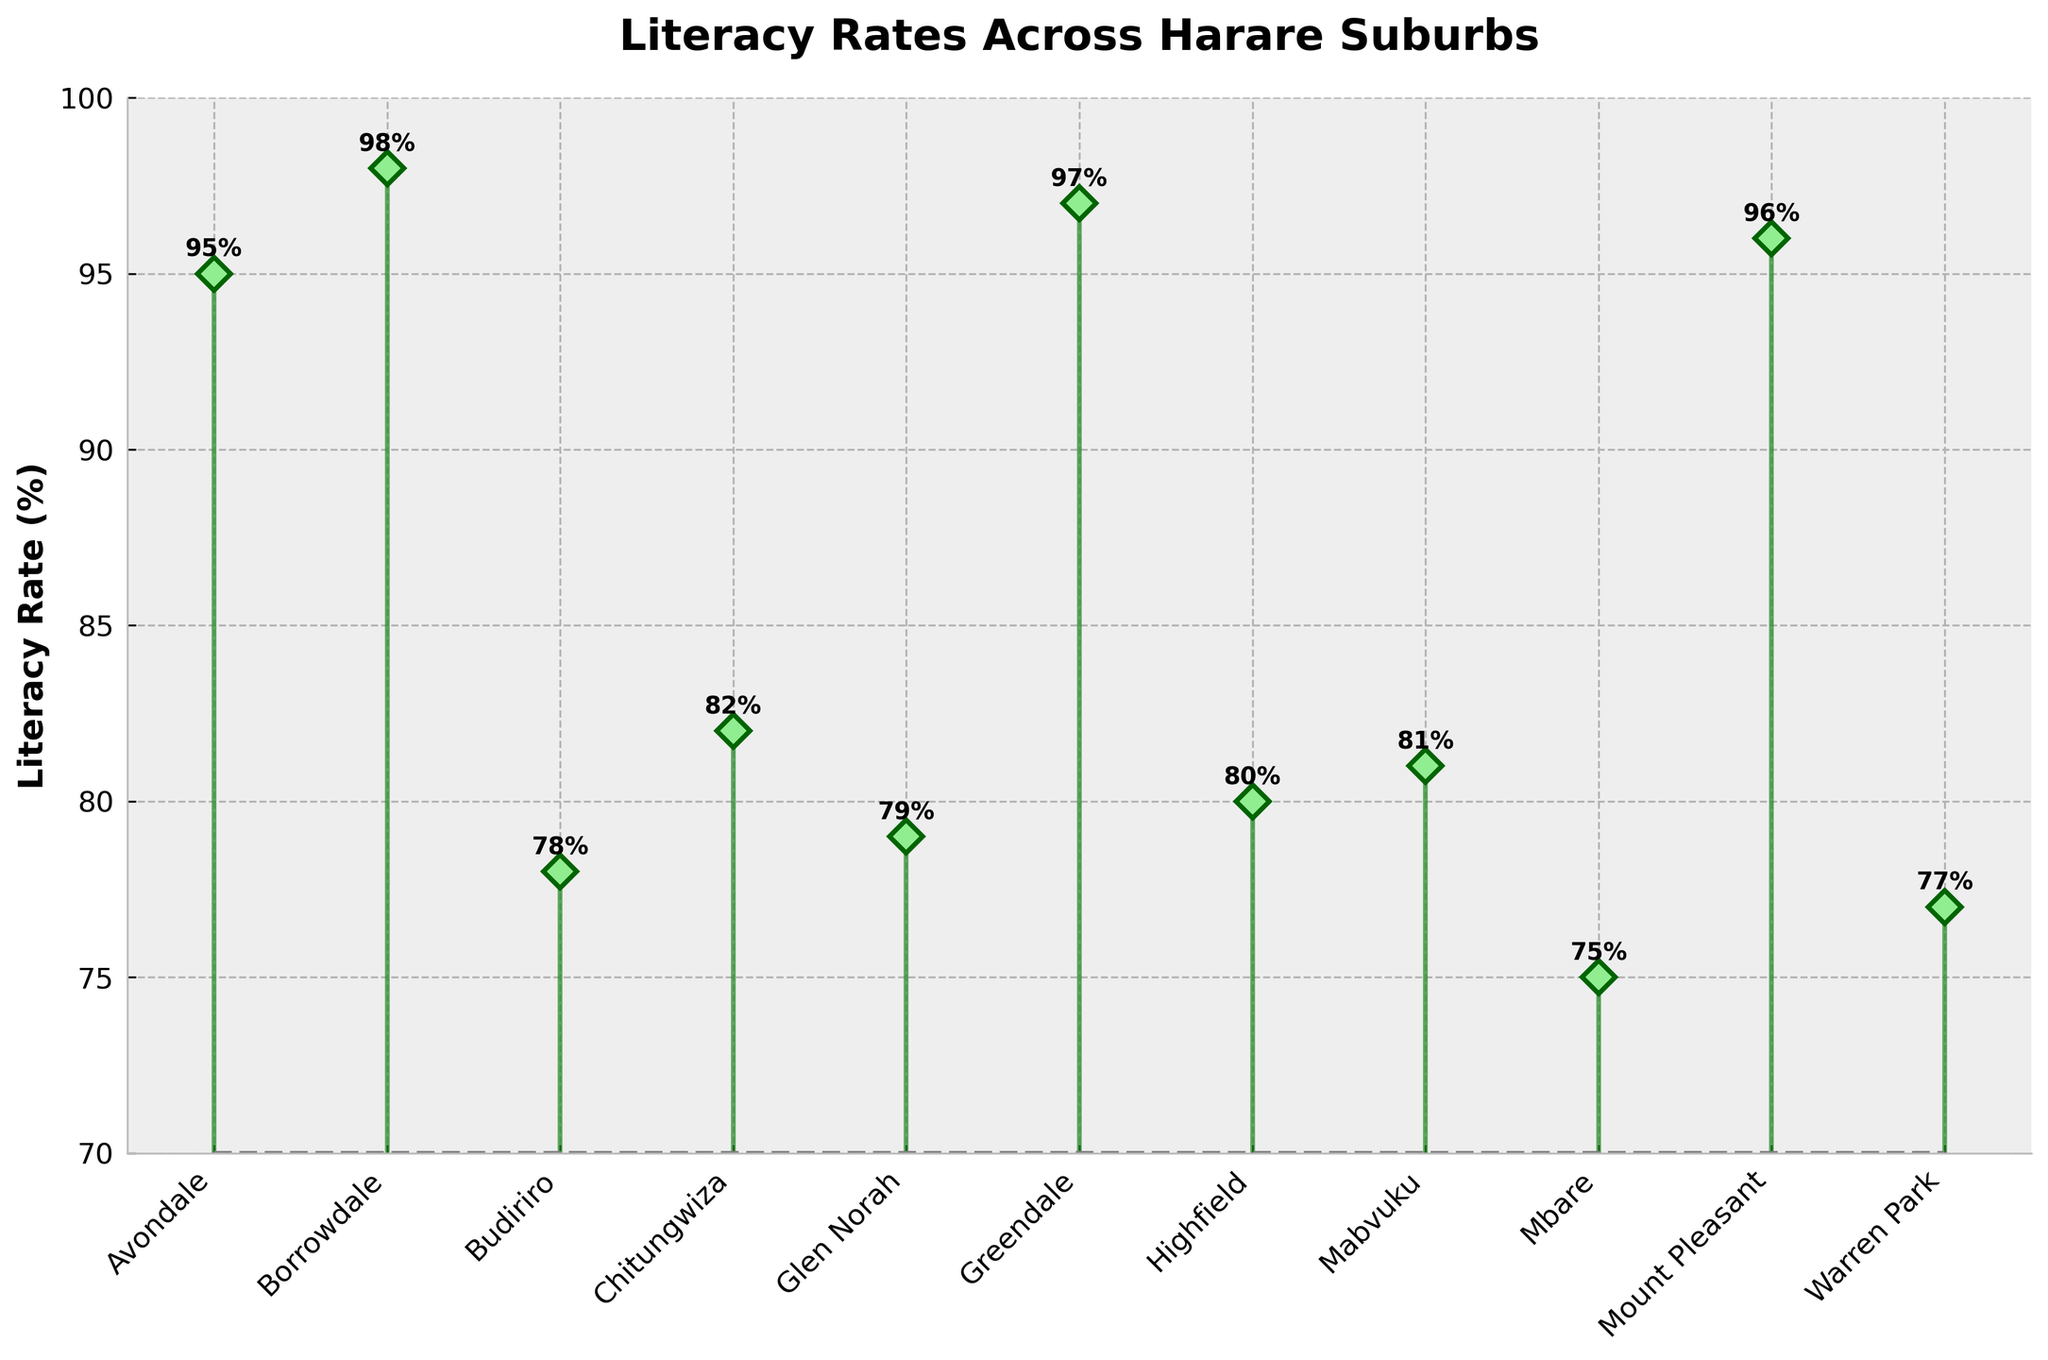What is the literacy rate of Borrowdale? Look at the point labeled Borrowdale on the x-axis and check its corresponding y-value. The annotated text says 98%.
Answer: 98% How many suburbs have literacy rates below 80%? Identify the points with y-values below 80% on the plot. There are markers at Budiriro, Glen Norah, and Mbare, totaling 3 suburbs.
Answer: 3 What is the suburb with the lowest literacy rate? Find the point with the smallest y-value on the plot. Mbare has a literacy rate of 75%, which is the lowest.
Answer: Mbare What is the average literacy rate across all the suburbs? Sum all the literacy rates and divide by the number of suburbs. The rates are (95 + 98 + 78 + 82 + 79 + 97 + 80 + 81 + 75 + 96 + 77). The sum is 938, and there are 11 suburbs, so the average is 938/11.
Answer: 85.27% What is the difference in literacy rates between Highfield and Mabvuku? Locate the literacy rates for Highfield (80%) and Mabvuku (81%). Calculate the difference: 81% - 80%.
Answer: 1% Which suburb has a literacy rate closest to 95%? Find the suburb with the rate nearest to 95%. Avondale and Mt Pleasant also have a rate of 95%, making them equally close.
Answer: Avondale or Mount Pleasant How many suburbs have a literacy rate of 90% or higher? Identify the points with y-values of 90% or more on the plot. These are Avondale, Borrowdale, Greendale, and Mt Pleasant, totaling 4 suburbs.
Answer: 4 What is the median literacy rate? Arrange the literacy rates in ascending order: 75, 77, 78, 79, 80, 81, 82, 95, 96, 97, 98. The middle value (6th in order) is 81%.
Answer: 81% What is the range of the literacy rates in the suburbs? Subtract the lowest literacy rate (Mbare, 75%) from the highest (Borrowdale, 98%). The range is 98% - 75%.
Answer: 23% What color is used for the baseline on the plot? Check the color of the line at the bottom of the stems. It's gray.
Answer: Gray 